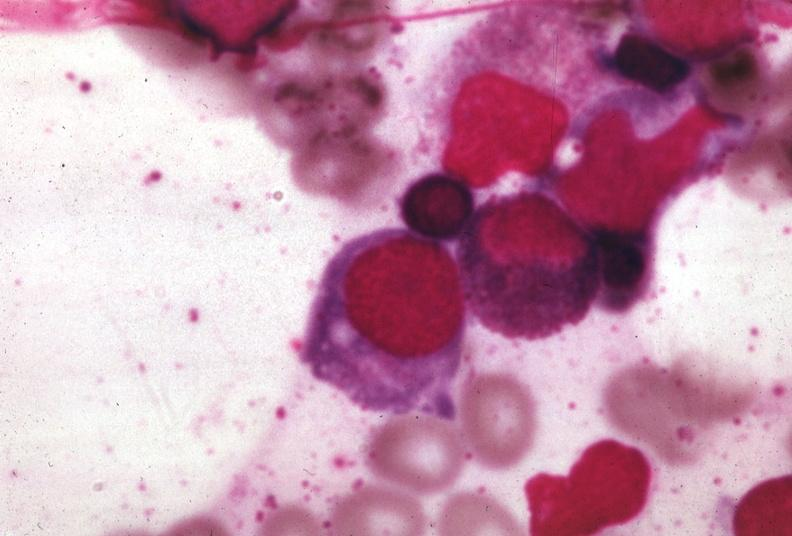s palmar crease normal present?
Answer the question using a single word or phrase. No 